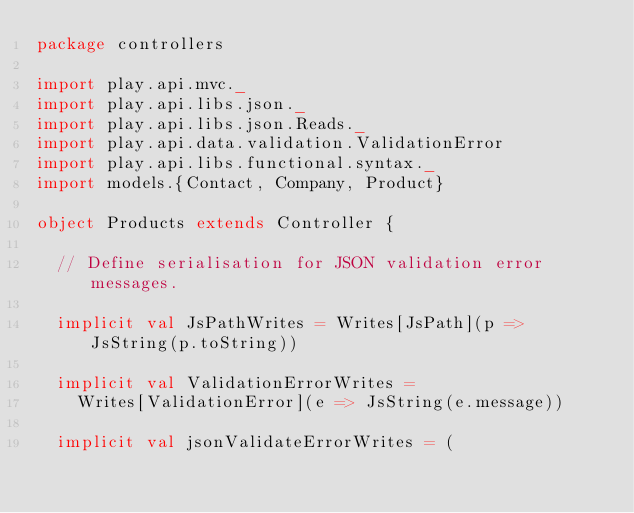Convert code to text. <code><loc_0><loc_0><loc_500><loc_500><_Scala_>package controllers

import play.api.mvc._
import play.api.libs.json._
import play.api.libs.json.Reads._
import play.api.data.validation.ValidationError
import play.api.libs.functional.syntax._
import models.{Contact, Company, Product}

object Products extends Controller {

  // Define serialisation for JSON validation error messages.

  implicit val JsPathWrites = Writes[JsPath](p => JsString(p.toString))

  implicit val ValidationErrorWrites =
    Writes[ValidationError](e => JsString(e.message))

  implicit val jsonValidateErrorWrites = (</code> 